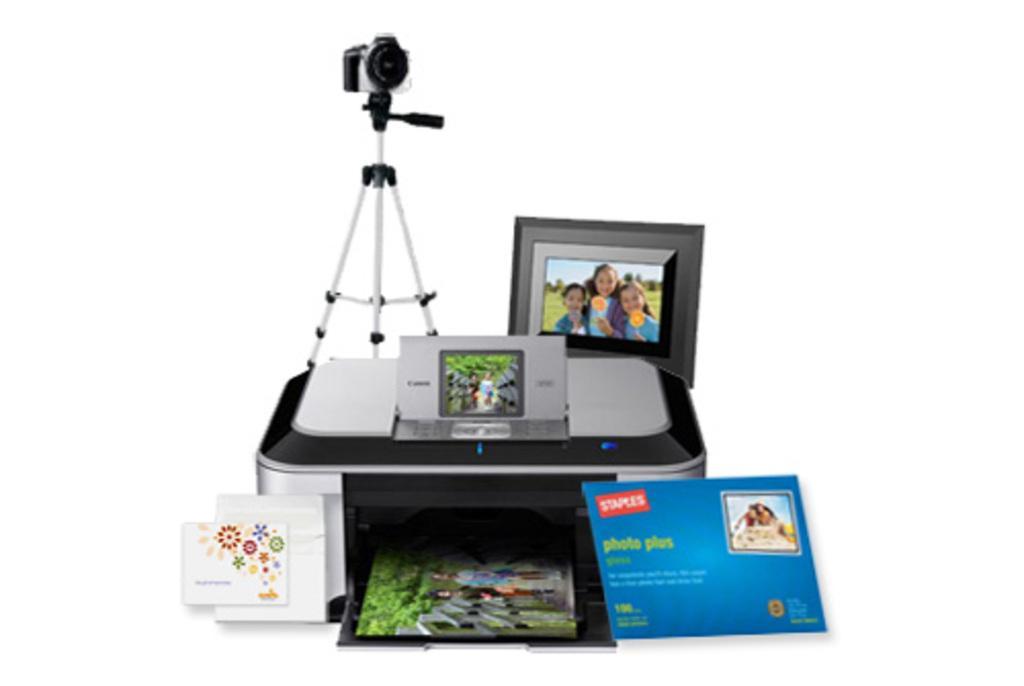Can you describe this image briefly? In this image there are some photo frames, cards, camera and some device. 